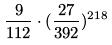<formula> <loc_0><loc_0><loc_500><loc_500>\frac { 9 } { 1 1 2 } \cdot ( \frac { 2 7 } { 3 9 2 } ) ^ { 2 1 8 }</formula> 